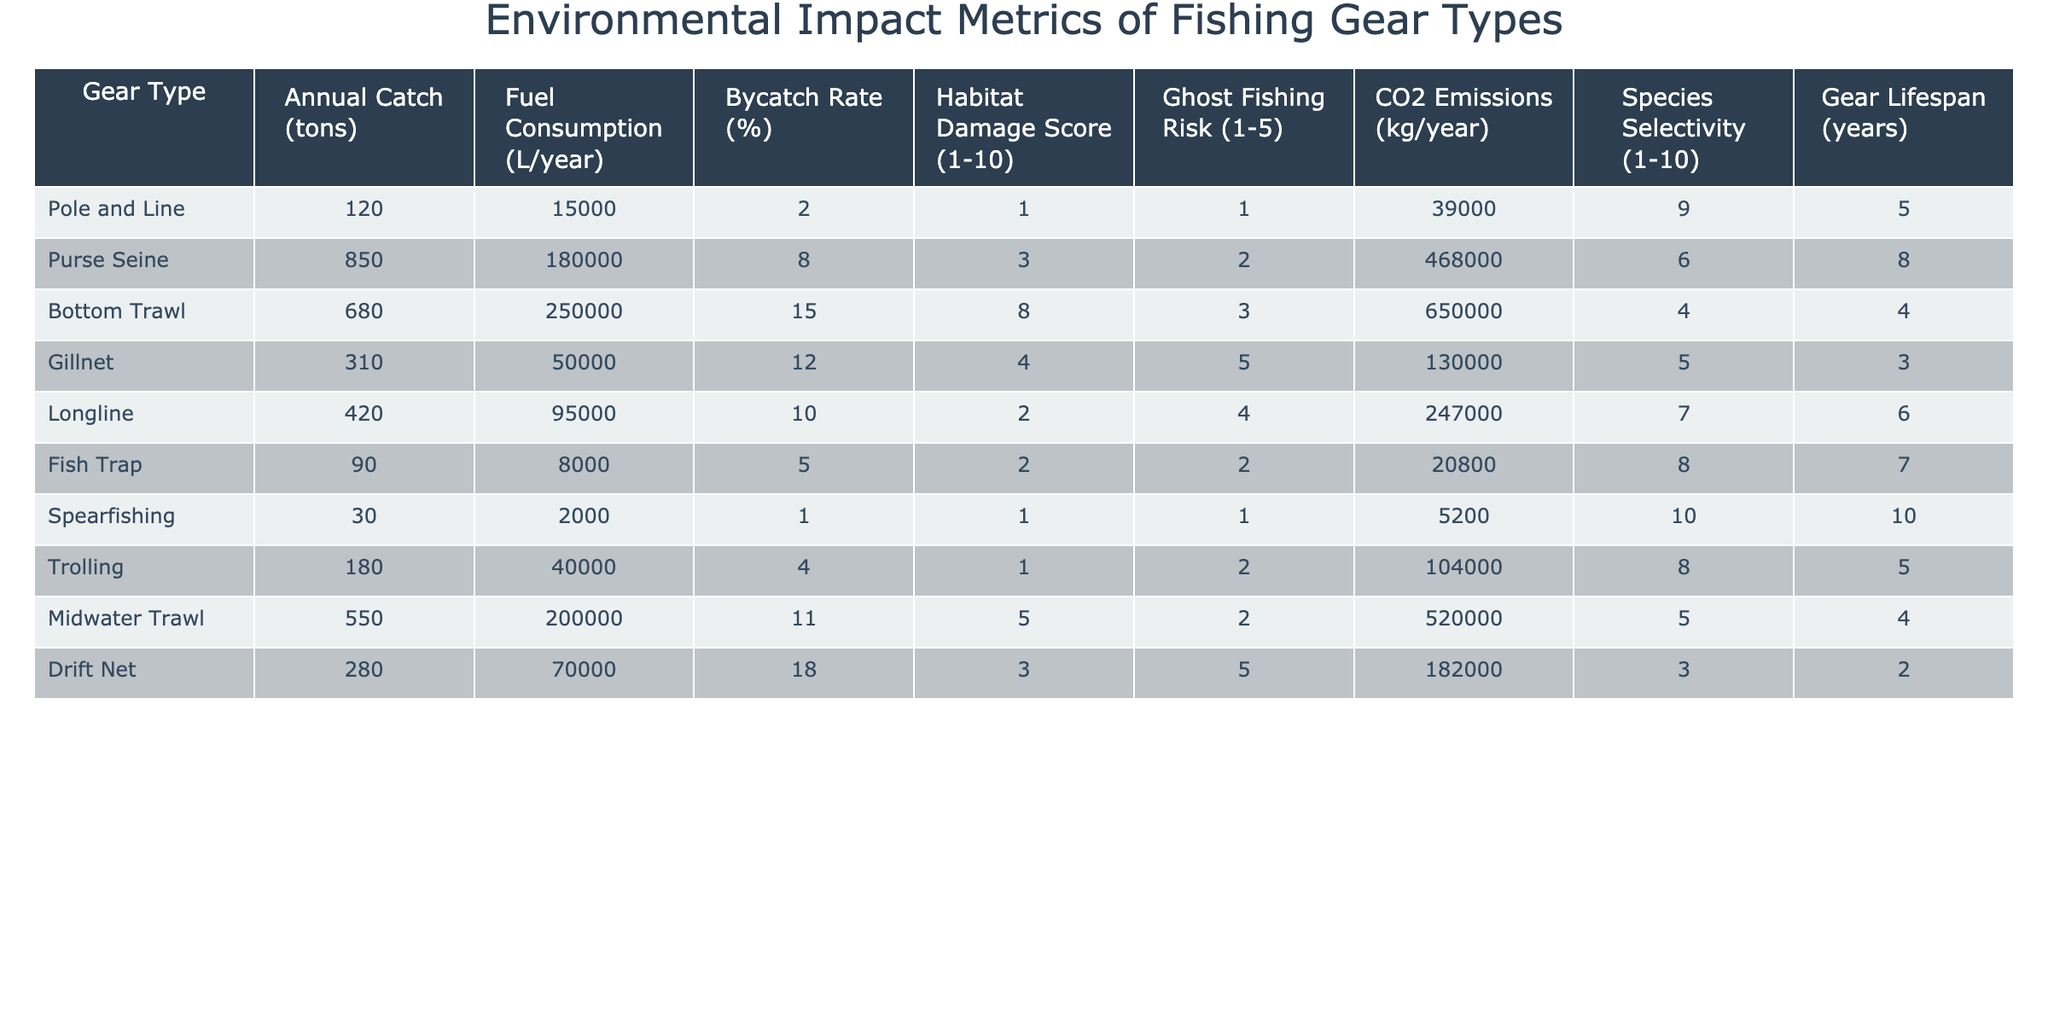What is the bycatch rate of the Bottom Trawl gear type? The bycatch rate for Bottom Trawl is specifically listed in the table, which shows that it is 15%.
Answer: 15% Which fishing gear type has the highest annual catch? By looking at the 'Annual Catch (tons)' column, we can see that the Purse Seine gear type has the highest value at 850 tons.
Answer: 850 tons What is the total fuel consumption for all gear types combined? To find the total fuel consumption, we sum all the values in the 'Fuel Consumption (L/year)' column: 15000 + 180000 + 250000 + 50000 + 95000 + 8000 + 2000 + 40000 + 200000 + 70000 = 1000000 L/year.
Answer: 1,000,000 L/year Which gear type has the lowest habitat damage score? By examining the 'Habitat Damage Score' column, we see that the Pole and Line gear type has the lowest score of 1.
Answer: 1 What is the species selectivity score for Fish Trap? The table indicates that the species selectivity score for Fish Trap is 8.
Answer: 8 Are CO2 emissions higher for Bottom Trawl than for Gillnet? Since Bottom Trawl has CO2 emissions of 650000 kg/year and Gillnet has 130000 kg/year, we can conclude that Bottom Trawl's emissions are higher.
Answer: Yes What is the average CO2 emissions across all gear types? First, we sum all CO2 emissions: 39000 + 468000 + 650000 + 130000 + 247000 + 20800 + 5200 + 104000 + 520000 + 182000 = 2200000 kg/year. There are 10 gear types, so the average is 2200000/10 = 220000 kg/year.
Answer: 220,000 kg/year Which gear type has the highest ghost fishing risk and what is its score? The table indicates that the Bottom Trawl gear type has the highest ghost fishing risk score of 3, which is the maximum listed along with Gillnet.
Answer: 3 (Bottom Trawl and Gillnet) What is the difference in bycatch rates between the Purse Seine and the Spearfishing gear types? Looking at the bycatch rates, Purse Seine has 8% and Spearfishing has 1%. The difference is 8% - 1% = 7%.
Answer: 7% How many years is the average gear lifespan of the fishing methods listed? Summing the gear lifespans: 5 + 8 + 4 + 3 + 6 + 7 + 10 + 5 + 4 + 2 = 54 years and dividing by 10 gives an average of 54/10 = 5.4 years.
Answer: 5.4 years 